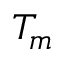<formula> <loc_0><loc_0><loc_500><loc_500>T _ { m }</formula> 